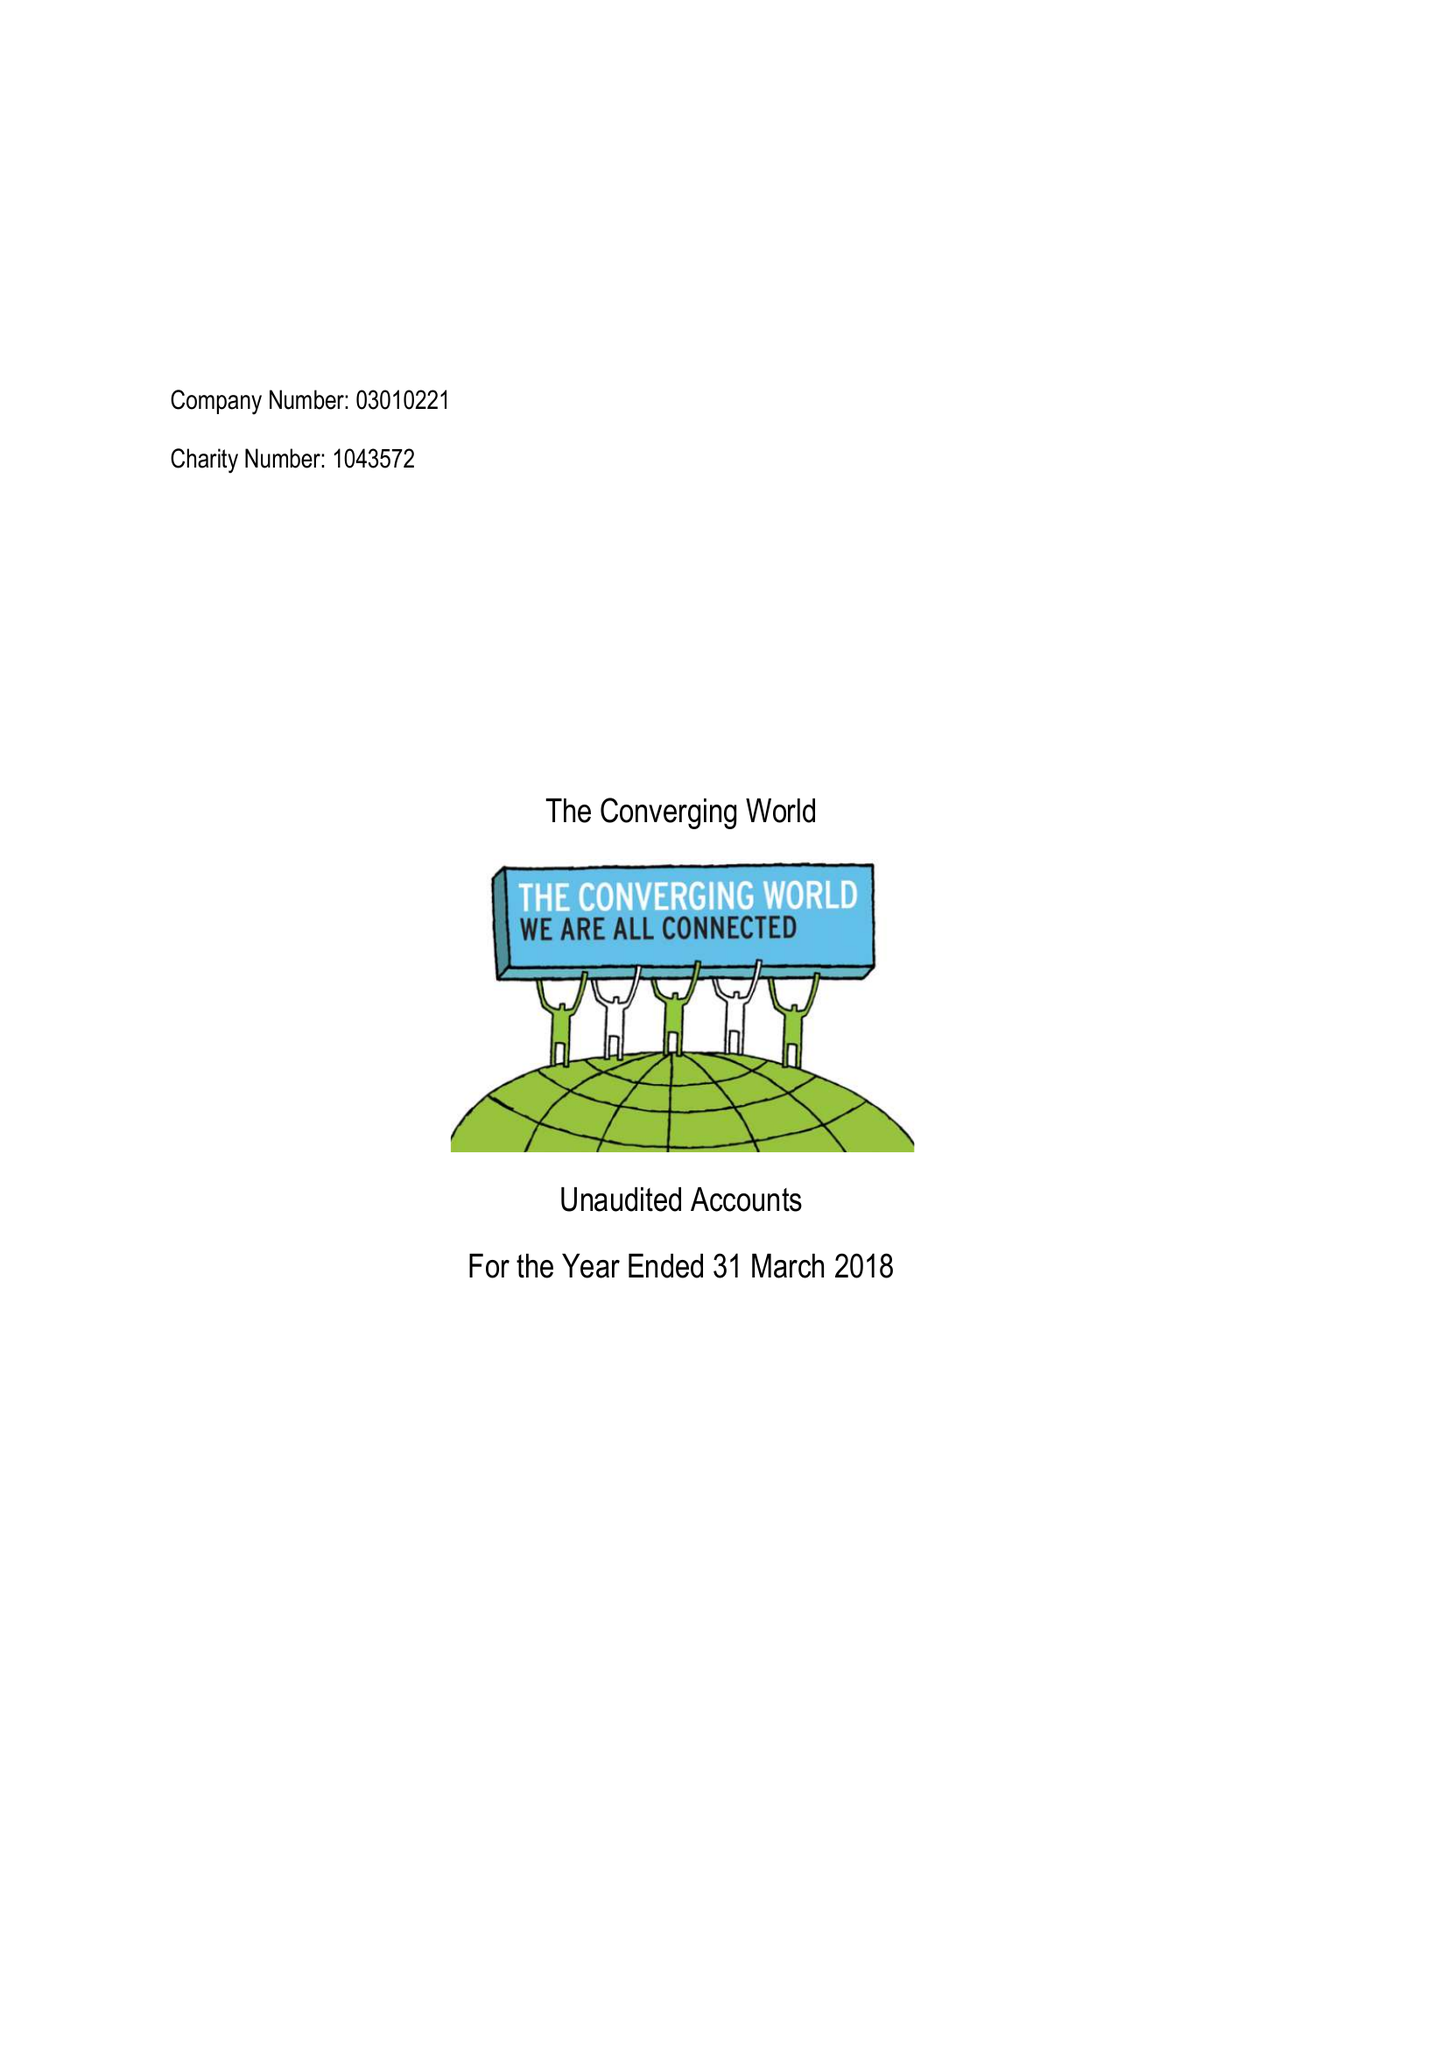What is the value for the income_annually_in_british_pounds?
Answer the question using a single word or phrase. 113342.00 